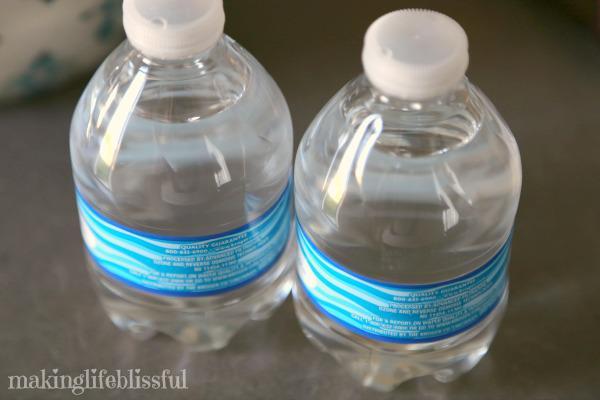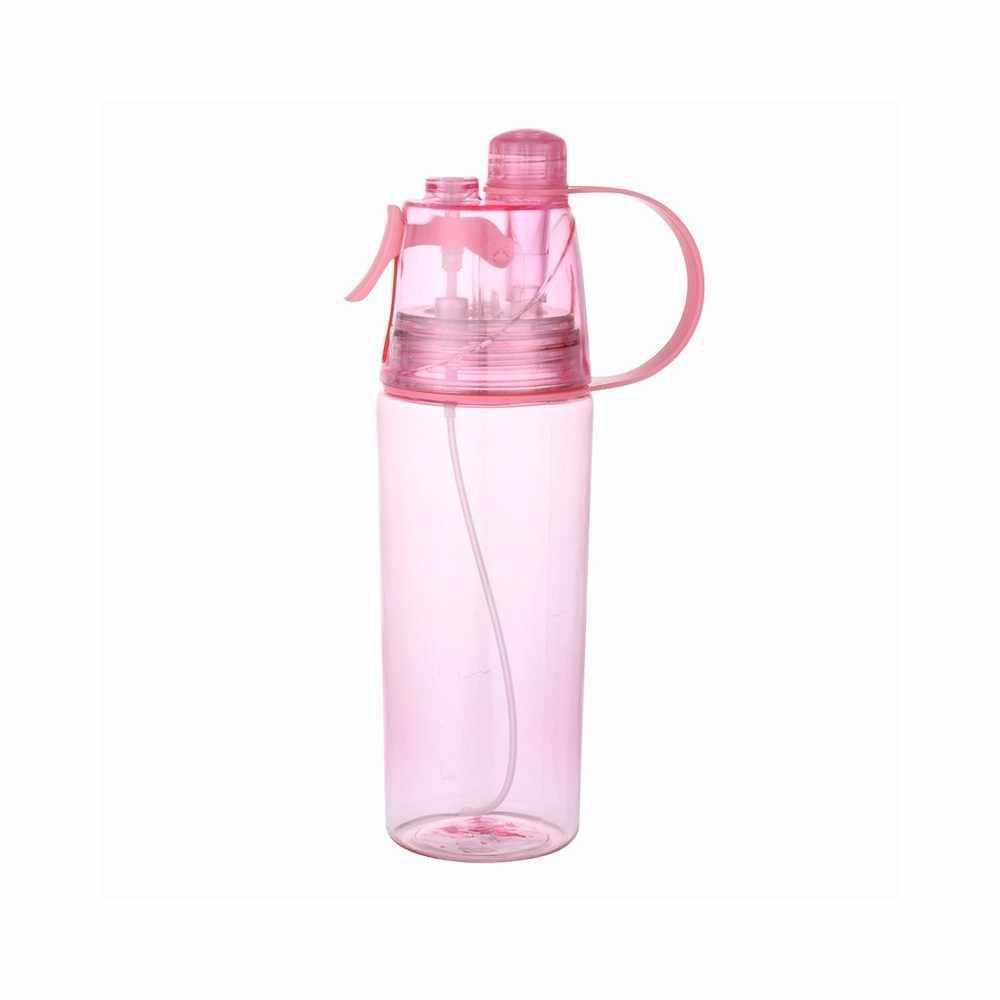The first image is the image on the left, the second image is the image on the right. Assess this claim about the two images: "There are exactly two bottles.". Correct or not? Answer yes or no. No. The first image is the image on the left, the second image is the image on the right. Given the left and right images, does the statement "One of the bottles is closed and has a straw down the middle, a loop on the side, and a trigger on the opposite side." hold true? Answer yes or no. Yes. 